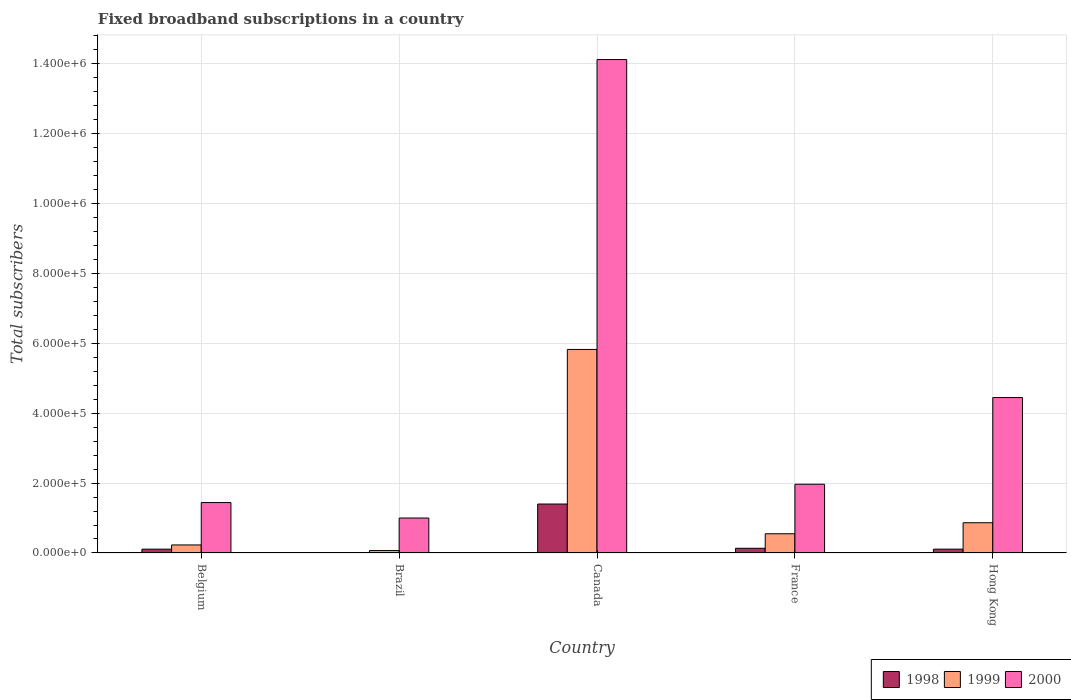How many groups of bars are there?
Make the answer very short. 5. Are the number of bars on each tick of the X-axis equal?
Your response must be concise. Yes. How many bars are there on the 3rd tick from the left?
Make the answer very short. 3. What is the label of the 4th group of bars from the left?
Offer a terse response. France. What is the number of broadband subscriptions in 1999 in Brazil?
Provide a succinct answer. 7000. Across all countries, what is the maximum number of broadband subscriptions in 2000?
Your answer should be very brief. 1.41e+06. Across all countries, what is the minimum number of broadband subscriptions in 1998?
Your answer should be very brief. 1000. In which country was the number of broadband subscriptions in 2000 maximum?
Make the answer very short. Canada. What is the total number of broadband subscriptions in 2000 in the graph?
Offer a very short reply. 2.30e+06. What is the difference between the number of broadband subscriptions in 1999 in Belgium and that in Canada?
Make the answer very short. -5.59e+05. What is the difference between the number of broadband subscriptions in 1999 in France and the number of broadband subscriptions in 2000 in Belgium?
Keep it short and to the point. -8.92e+04. What is the average number of broadband subscriptions in 1999 per country?
Offer a terse response. 1.51e+05. What is the difference between the number of broadband subscriptions of/in 1998 and number of broadband subscriptions of/in 2000 in Hong Kong?
Your answer should be very brief. -4.33e+05. In how many countries, is the number of broadband subscriptions in 1998 greater than 320000?
Give a very brief answer. 0. What is the ratio of the number of broadband subscriptions in 1999 in Canada to that in Hong Kong?
Ensure brevity in your answer.  6.73. Is the number of broadband subscriptions in 1998 in Brazil less than that in Canada?
Provide a succinct answer. Yes. Is the difference between the number of broadband subscriptions in 1998 in Belgium and Brazil greater than the difference between the number of broadband subscriptions in 2000 in Belgium and Brazil?
Provide a succinct answer. No. What is the difference between the highest and the second highest number of broadband subscriptions in 2000?
Your answer should be very brief. -2.48e+05. What is the difference between the highest and the lowest number of broadband subscriptions in 1998?
Give a very brief answer. 1.39e+05. In how many countries, is the number of broadband subscriptions in 1999 greater than the average number of broadband subscriptions in 1999 taken over all countries?
Your response must be concise. 1. What does the 3rd bar from the right in Brazil represents?
Your answer should be compact. 1998. Is it the case that in every country, the sum of the number of broadband subscriptions in 1998 and number of broadband subscriptions in 1999 is greater than the number of broadband subscriptions in 2000?
Your answer should be very brief. No. Are all the bars in the graph horizontal?
Keep it short and to the point. No. How many countries are there in the graph?
Provide a succinct answer. 5. What is the difference between two consecutive major ticks on the Y-axis?
Ensure brevity in your answer.  2.00e+05. Are the values on the major ticks of Y-axis written in scientific E-notation?
Make the answer very short. Yes. Does the graph contain any zero values?
Give a very brief answer. No. Does the graph contain grids?
Your answer should be very brief. Yes. Where does the legend appear in the graph?
Your answer should be very brief. Bottom right. What is the title of the graph?
Provide a succinct answer. Fixed broadband subscriptions in a country. Does "1983" appear as one of the legend labels in the graph?
Make the answer very short. No. What is the label or title of the Y-axis?
Your answer should be very brief. Total subscribers. What is the Total subscribers in 1998 in Belgium?
Offer a very short reply. 1.09e+04. What is the Total subscribers of 1999 in Belgium?
Keep it short and to the point. 2.30e+04. What is the Total subscribers in 2000 in Belgium?
Ensure brevity in your answer.  1.44e+05. What is the Total subscribers of 1999 in Brazil?
Your answer should be compact. 7000. What is the Total subscribers of 1999 in Canada?
Keep it short and to the point. 5.82e+05. What is the Total subscribers in 2000 in Canada?
Offer a very short reply. 1.41e+06. What is the Total subscribers in 1998 in France?
Your answer should be compact. 1.35e+04. What is the Total subscribers in 1999 in France?
Provide a succinct answer. 5.50e+04. What is the Total subscribers of 2000 in France?
Provide a succinct answer. 1.97e+05. What is the Total subscribers in 1998 in Hong Kong?
Keep it short and to the point. 1.10e+04. What is the Total subscribers of 1999 in Hong Kong?
Your answer should be compact. 8.65e+04. What is the Total subscribers in 2000 in Hong Kong?
Make the answer very short. 4.44e+05. Across all countries, what is the maximum Total subscribers of 1998?
Provide a succinct answer. 1.40e+05. Across all countries, what is the maximum Total subscribers in 1999?
Your answer should be very brief. 5.82e+05. Across all countries, what is the maximum Total subscribers of 2000?
Ensure brevity in your answer.  1.41e+06. Across all countries, what is the minimum Total subscribers in 1998?
Offer a very short reply. 1000. Across all countries, what is the minimum Total subscribers of 1999?
Provide a short and direct response. 7000. Across all countries, what is the minimum Total subscribers in 2000?
Your response must be concise. 1.00e+05. What is the total Total subscribers of 1998 in the graph?
Your answer should be compact. 1.76e+05. What is the total Total subscribers of 1999 in the graph?
Provide a short and direct response. 7.53e+05. What is the total Total subscribers of 2000 in the graph?
Provide a succinct answer. 2.30e+06. What is the difference between the Total subscribers of 1998 in Belgium and that in Brazil?
Keep it short and to the point. 9924. What is the difference between the Total subscribers in 1999 in Belgium and that in Brazil?
Offer a very short reply. 1.60e+04. What is the difference between the Total subscribers of 2000 in Belgium and that in Brazil?
Offer a very short reply. 4.42e+04. What is the difference between the Total subscribers in 1998 in Belgium and that in Canada?
Your answer should be compact. -1.29e+05. What is the difference between the Total subscribers in 1999 in Belgium and that in Canada?
Provide a short and direct response. -5.59e+05. What is the difference between the Total subscribers of 2000 in Belgium and that in Canada?
Make the answer very short. -1.27e+06. What is the difference between the Total subscribers of 1998 in Belgium and that in France?
Your answer should be compact. -2540. What is the difference between the Total subscribers in 1999 in Belgium and that in France?
Keep it short and to the point. -3.20e+04. What is the difference between the Total subscribers of 2000 in Belgium and that in France?
Give a very brief answer. -5.24e+04. What is the difference between the Total subscribers in 1998 in Belgium and that in Hong Kong?
Your answer should be very brief. -76. What is the difference between the Total subscribers in 1999 in Belgium and that in Hong Kong?
Your answer should be compact. -6.35e+04. What is the difference between the Total subscribers in 2000 in Belgium and that in Hong Kong?
Your response must be concise. -3.00e+05. What is the difference between the Total subscribers in 1998 in Brazil and that in Canada?
Make the answer very short. -1.39e+05. What is the difference between the Total subscribers of 1999 in Brazil and that in Canada?
Make the answer very short. -5.75e+05. What is the difference between the Total subscribers in 2000 in Brazil and that in Canada?
Ensure brevity in your answer.  -1.31e+06. What is the difference between the Total subscribers in 1998 in Brazil and that in France?
Provide a short and direct response. -1.25e+04. What is the difference between the Total subscribers in 1999 in Brazil and that in France?
Keep it short and to the point. -4.80e+04. What is the difference between the Total subscribers in 2000 in Brazil and that in France?
Provide a succinct answer. -9.66e+04. What is the difference between the Total subscribers of 1998 in Brazil and that in Hong Kong?
Offer a terse response. -10000. What is the difference between the Total subscribers of 1999 in Brazil and that in Hong Kong?
Your response must be concise. -7.95e+04. What is the difference between the Total subscribers of 2000 in Brazil and that in Hong Kong?
Your answer should be compact. -3.44e+05. What is the difference between the Total subscribers of 1998 in Canada and that in France?
Your response must be concise. 1.27e+05. What is the difference between the Total subscribers of 1999 in Canada and that in France?
Your answer should be very brief. 5.27e+05. What is the difference between the Total subscribers of 2000 in Canada and that in France?
Provide a short and direct response. 1.21e+06. What is the difference between the Total subscribers of 1998 in Canada and that in Hong Kong?
Offer a terse response. 1.29e+05. What is the difference between the Total subscribers in 1999 in Canada and that in Hong Kong?
Offer a terse response. 4.96e+05. What is the difference between the Total subscribers in 2000 in Canada and that in Hong Kong?
Offer a terse response. 9.66e+05. What is the difference between the Total subscribers in 1998 in France and that in Hong Kong?
Your answer should be compact. 2464. What is the difference between the Total subscribers of 1999 in France and that in Hong Kong?
Your response must be concise. -3.15e+04. What is the difference between the Total subscribers in 2000 in France and that in Hong Kong?
Make the answer very short. -2.48e+05. What is the difference between the Total subscribers of 1998 in Belgium and the Total subscribers of 1999 in Brazil?
Provide a short and direct response. 3924. What is the difference between the Total subscribers in 1998 in Belgium and the Total subscribers in 2000 in Brazil?
Your response must be concise. -8.91e+04. What is the difference between the Total subscribers of 1999 in Belgium and the Total subscribers of 2000 in Brazil?
Your response must be concise. -7.70e+04. What is the difference between the Total subscribers in 1998 in Belgium and the Total subscribers in 1999 in Canada?
Your answer should be very brief. -5.71e+05. What is the difference between the Total subscribers in 1998 in Belgium and the Total subscribers in 2000 in Canada?
Keep it short and to the point. -1.40e+06. What is the difference between the Total subscribers in 1999 in Belgium and the Total subscribers in 2000 in Canada?
Provide a succinct answer. -1.39e+06. What is the difference between the Total subscribers of 1998 in Belgium and the Total subscribers of 1999 in France?
Offer a very short reply. -4.41e+04. What is the difference between the Total subscribers of 1998 in Belgium and the Total subscribers of 2000 in France?
Your answer should be compact. -1.86e+05. What is the difference between the Total subscribers in 1999 in Belgium and the Total subscribers in 2000 in France?
Provide a short and direct response. -1.74e+05. What is the difference between the Total subscribers of 1998 in Belgium and the Total subscribers of 1999 in Hong Kong?
Offer a terse response. -7.55e+04. What is the difference between the Total subscribers of 1998 in Belgium and the Total subscribers of 2000 in Hong Kong?
Provide a succinct answer. -4.34e+05. What is the difference between the Total subscribers in 1999 in Belgium and the Total subscribers in 2000 in Hong Kong?
Ensure brevity in your answer.  -4.21e+05. What is the difference between the Total subscribers in 1998 in Brazil and the Total subscribers in 1999 in Canada?
Offer a terse response. -5.81e+05. What is the difference between the Total subscribers in 1998 in Brazil and the Total subscribers in 2000 in Canada?
Your answer should be very brief. -1.41e+06. What is the difference between the Total subscribers of 1999 in Brazil and the Total subscribers of 2000 in Canada?
Offer a terse response. -1.40e+06. What is the difference between the Total subscribers of 1998 in Brazil and the Total subscribers of 1999 in France?
Give a very brief answer. -5.40e+04. What is the difference between the Total subscribers in 1998 in Brazil and the Total subscribers in 2000 in France?
Provide a short and direct response. -1.96e+05. What is the difference between the Total subscribers of 1999 in Brazil and the Total subscribers of 2000 in France?
Provide a succinct answer. -1.90e+05. What is the difference between the Total subscribers in 1998 in Brazil and the Total subscribers in 1999 in Hong Kong?
Provide a succinct answer. -8.55e+04. What is the difference between the Total subscribers in 1998 in Brazil and the Total subscribers in 2000 in Hong Kong?
Your answer should be very brief. -4.43e+05. What is the difference between the Total subscribers in 1999 in Brazil and the Total subscribers in 2000 in Hong Kong?
Your answer should be compact. -4.37e+05. What is the difference between the Total subscribers in 1998 in Canada and the Total subscribers in 1999 in France?
Your answer should be compact. 8.50e+04. What is the difference between the Total subscribers in 1998 in Canada and the Total subscribers in 2000 in France?
Offer a very short reply. -5.66e+04. What is the difference between the Total subscribers of 1999 in Canada and the Total subscribers of 2000 in France?
Your answer should be compact. 3.85e+05. What is the difference between the Total subscribers of 1998 in Canada and the Total subscribers of 1999 in Hong Kong?
Give a very brief answer. 5.35e+04. What is the difference between the Total subscribers of 1998 in Canada and the Total subscribers of 2000 in Hong Kong?
Provide a succinct answer. -3.04e+05. What is the difference between the Total subscribers of 1999 in Canada and the Total subscribers of 2000 in Hong Kong?
Provide a short and direct response. 1.38e+05. What is the difference between the Total subscribers of 1998 in France and the Total subscribers of 1999 in Hong Kong?
Give a very brief answer. -7.30e+04. What is the difference between the Total subscribers in 1998 in France and the Total subscribers in 2000 in Hong Kong?
Your response must be concise. -4.31e+05. What is the difference between the Total subscribers in 1999 in France and the Total subscribers in 2000 in Hong Kong?
Your response must be concise. -3.89e+05. What is the average Total subscribers of 1998 per country?
Make the answer very short. 3.53e+04. What is the average Total subscribers in 1999 per country?
Give a very brief answer. 1.51e+05. What is the average Total subscribers of 2000 per country?
Your answer should be compact. 4.59e+05. What is the difference between the Total subscribers of 1998 and Total subscribers of 1999 in Belgium?
Ensure brevity in your answer.  -1.21e+04. What is the difference between the Total subscribers in 1998 and Total subscribers in 2000 in Belgium?
Offer a very short reply. -1.33e+05. What is the difference between the Total subscribers of 1999 and Total subscribers of 2000 in Belgium?
Ensure brevity in your answer.  -1.21e+05. What is the difference between the Total subscribers of 1998 and Total subscribers of 1999 in Brazil?
Keep it short and to the point. -6000. What is the difference between the Total subscribers of 1998 and Total subscribers of 2000 in Brazil?
Give a very brief answer. -9.90e+04. What is the difference between the Total subscribers in 1999 and Total subscribers in 2000 in Brazil?
Provide a succinct answer. -9.30e+04. What is the difference between the Total subscribers of 1998 and Total subscribers of 1999 in Canada?
Give a very brief answer. -4.42e+05. What is the difference between the Total subscribers of 1998 and Total subscribers of 2000 in Canada?
Your response must be concise. -1.27e+06. What is the difference between the Total subscribers of 1999 and Total subscribers of 2000 in Canada?
Make the answer very short. -8.29e+05. What is the difference between the Total subscribers of 1998 and Total subscribers of 1999 in France?
Your answer should be compact. -4.15e+04. What is the difference between the Total subscribers in 1998 and Total subscribers in 2000 in France?
Your answer should be compact. -1.83e+05. What is the difference between the Total subscribers of 1999 and Total subscribers of 2000 in France?
Keep it short and to the point. -1.42e+05. What is the difference between the Total subscribers of 1998 and Total subscribers of 1999 in Hong Kong?
Keep it short and to the point. -7.55e+04. What is the difference between the Total subscribers of 1998 and Total subscribers of 2000 in Hong Kong?
Your response must be concise. -4.33e+05. What is the difference between the Total subscribers in 1999 and Total subscribers in 2000 in Hong Kong?
Your answer should be very brief. -3.58e+05. What is the ratio of the Total subscribers of 1998 in Belgium to that in Brazil?
Give a very brief answer. 10.92. What is the ratio of the Total subscribers of 1999 in Belgium to that in Brazil?
Ensure brevity in your answer.  3.29. What is the ratio of the Total subscribers in 2000 in Belgium to that in Brazil?
Offer a terse response. 1.44. What is the ratio of the Total subscribers of 1998 in Belgium to that in Canada?
Make the answer very short. 0.08. What is the ratio of the Total subscribers in 1999 in Belgium to that in Canada?
Ensure brevity in your answer.  0.04. What is the ratio of the Total subscribers of 2000 in Belgium to that in Canada?
Ensure brevity in your answer.  0.1. What is the ratio of the Total subscribers in 1998 in Belgium to that in France?
Offer a very short reply. 0.81. What is the ratio of the Total subscribers in 1999 in Belgium to that in France?
Offer a terse response. 0.42. What is the ratio of the Total subscribers of 2000 in Belgium to that in France?
Your answer should be very brief. 0.73. What is the ratio of the Total subscribers of 1999 in Belgium to that in Hong Kong?
Ensure brevity in your answer.  0.27. What is the ratio of the Total subscribers of 2000 in Belgium to that in Hong Kong?
Offer a very short reply. 0.32. What is the ratio of the Total subscribers in 1998 in Brazil to that in Canada?
Give a very brief answer. 0.01. What is the ratio of the Total subscribers in 1999 in Brazil to that in Canada?
Offer a very short reply. 0.01. What is the ratio of the Total subscribers of 2000 in Brazil to that in Canada?
Your response must be concise. 0.07. What is the ratio of the Total subscribers in 1998 in Brazil to that in France?
Give a very brief answer. 0.07. What is the ratio of the Total subscribers in 1999 in Brazil to that in France?
Provide a succinct answer. 0.13. What is the ratio of the Total subscribers of 2000 in Brazil to that in France?
Your answer should be compact. 0.51. What is the ratio of the Total subscribers in 1998 in Brazil to that in Hong Kong?
Provide a succinct answer. 0.09. What is the ratio of the Total subscribers of 1999 in Brazil to that in Hong Kong?
Provide a short and direct response. 0.08. What is the ratio of the Total subscribers in 2000 in Brazil to that in Hong Kong?
Your answer should be very brief. 0.23. What is the ratio of the Total subscribers in 1998 in Canada to that in France?
Give a very brief answer. 10.4. What is the ratio of the Total subscribers of 1999 in Canada to that in France?
Offer a terse response. 10.58. What is the ratio of the Total subscribers of 2000 in Canada to that in France?
Offer a terse response. 7.18. What is the ratio of the Total subscribers of 1998 in Canada to that in Hong Kong?
Provide a short and direct response. 12.73. What is the ratio of the Total subscribers in 1999 in Canada to that in Hong Kong?
Your response must be concise. 6.73. What is the ratio of the Total subscribers of 2000 in Canada to that in Hong Kong?
Offer a terse response. 3.17. What is the ratio of the Total subscribers in 1998 in France to that in Hong Kong?
Your answer should be very brief. 1.22. What is the ratio of the Total subscribers in 1999 in France to that in Hong Kong?
Ensure brevity in your answer.  0.64. What is the ratio of the Total subscribers in 2000 in France to that in Hong Kong?
Offer a very short reply. 0.44. What is the difference between the highest and the second highest Total subscribers in 1998?
Give a very brief answer. 1.27e+05. What is the difference between the highest and the second highest Total subscribers in 1999?
Provide a short and direct response. 4.96e+05. What is the difference between the highest and the second highest Total subscribers in 2000?
Ensure brevity in your answer.  9.66e+05. What is the difference between the highest and the lowest Total subscribers of 1998?
Offer a very short reply. 1.39e+05. What is the difference between the highest and the lowest Total subscribers of 1999?
Your response must be concise. 5.75e+05. What is the difference between the highest and the lowest Total subscribers of 2000?
Provide a short and direct response. 1.31e+06. 